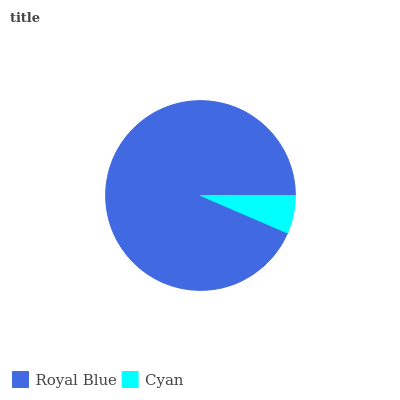Is Cyan the minimum?
Answer yes or no. Yes. Is Royal Blue the maximum?
Answer yes or no. Yes. Is Cyan the maximum?
Answer yes or no. No. Is Royal Blue greater than Cyan?
Answer yes or no. Yes. Is Cyan less than Royal Blue?
Answer yes or no. Yes. Is Cyan greater than Royal Blue?
Answer yes or no. No. Is Royal Blue less than Cyan?
Answer yes or no. No. Is Royal Blue the high median?
Answer yes or no. Yes. Is Cyan the low median?
Answer yes or no. Yes. Is Cyan the high median?
Answer yes or no. No. Is Royal Blue the low median?
Answer yes or no. No. 